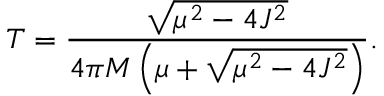Convert formula to latex. <formula><loc_0><loc_0><loc_500><loc_500>T = \frac { \sqrt { \mu ^ { 2 } - 4 J ^ { 2 } } } { 4 \pi M \left ( \mu + \sqrt { \mu ^ { 2 } - 4 J ^ { 2 } } \right ) } .</formula> 